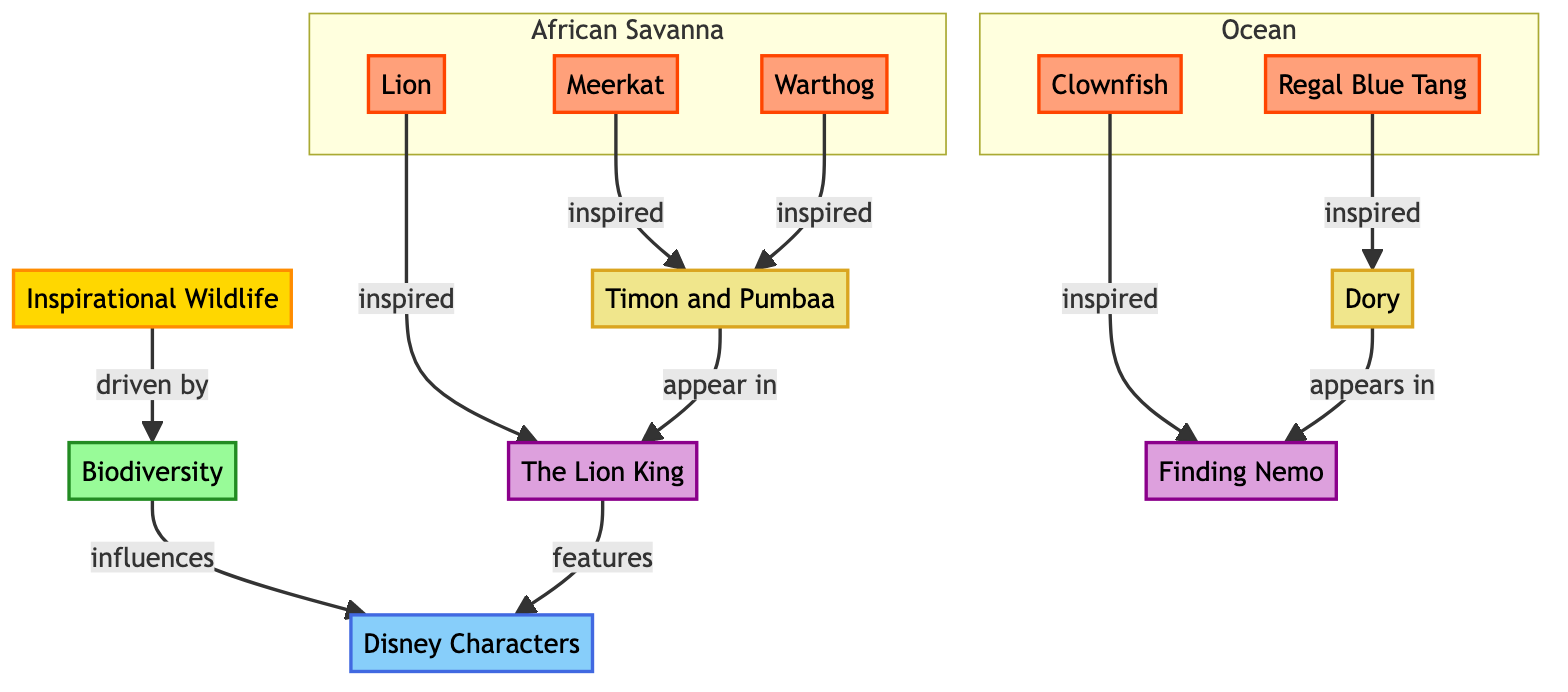What is the main category represented in the diagram? The main category is "Inspirational Wildlife," which is represented as "IW" in the diagram. This is the starting point and overarching theme of the flowchart.
Answer: Inspirational Wildlife How many types of species are listed in the diagram? There are four species listed: Lion, Meerkat, Warthog, Clownfish, and Regal Blue Tang, making a total of five species (counting Regal Blue Tang and Clownfish).
Answer: 5 Which Disney movie features the Lion? The Lion is associated with the movie "The Lion King," as indicated by the flow from LI to LK.
Answer: The Lion King What characters appear in "Finding Nemo"? The diagram shows that Dory is the only character listed as appearing in "Finding Nemo," connected directly from the species Regal Blue Tang.
Answer: Dory Which species inspired the characters Timon and Pumbaa? Timon is inspired by the Meerkat and Pumbaa by the Warthog, both of which are connected directly to TP.
Answer: Meerkat and Warthog How many Disney movies are influenced by biodiversity in the diagram? There are two Disney movies identified in the diagram: "The Lion King" and "Finding Nemo," indicating a count of two movies influenced by biodiversity.
Answer: 2 What does biodiversity influence according to the diagram? The diagram indicates that biodiversity influences "Disney Characters," as shown by the flow from BD to DC.
Answer: Disney Characters Which two animal species belong to the ocean subgraph? The two species in the ocean subgraph are Clownfish and Regal Blue Tang, as indicated in the section labeled "Ocean."
Answer: Clownfish and Regal Blue Tang Which character is inspired by the Clownfish? The character inspired by the Clownfish is Dory, as shown by the direct connection from CF (Clownfish) to DR (Dory).
Answer: Dory 